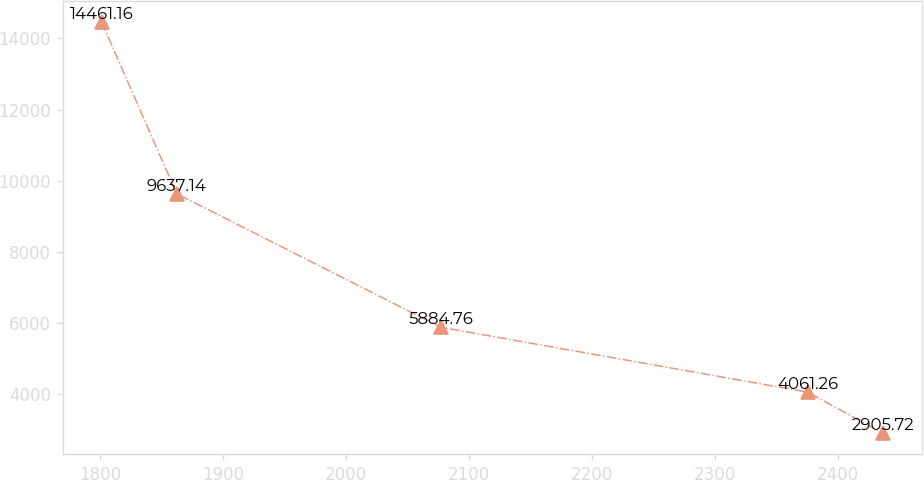Convert chart. <chart><loc_0><loc_0><loc_500><loc_500><line_chart><ecel><fcel>Unnamed: 1<nl><fcel>1801.22<fcel>14461.2<nl><fcel>1862.24<fcel>9637.14<nl><fcel>2077.02<fcel>5884.76<nl><fcel>2375.51<fcel>4061.26<nl><fcel>2436.53<fcel>2905.72<nl></chart> 